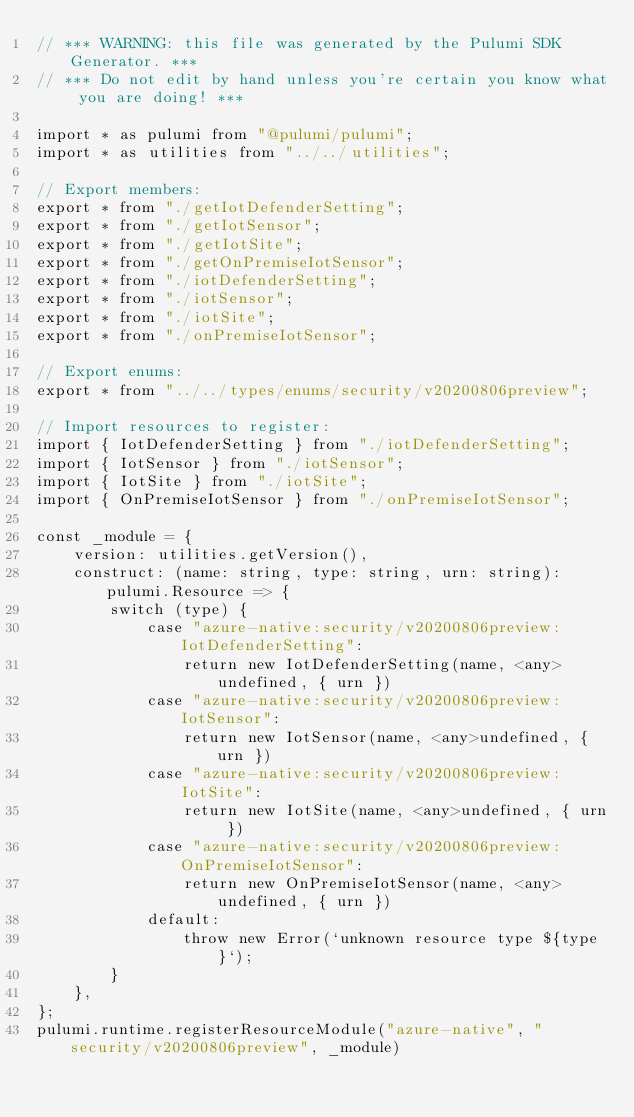Convert code to text. <code><loc_0><loc_0><loc_500><loc_500><_TypeScript_>// *** WARNING: this file was generated by the Pulumi SDK Generator. ***
// *** Do not edit by hand unless you're certain you know what you are doing! ***

import * as pulumi from "@pulumi/pulumi";
import * as utilities from "../../utilities";

// Export members:
export * from "./getIotDefenderSetting";
export * from "./getIotSensor";
export * from "./getIotSite";
export * from "./getOnPremiseIotSensor";
export * from "./iotDefenderSetting";
export * from "./iotSensor";
export * from "./iotSite";
export * from "./onPremiseIotSensor";

// Export enums:
export * from "../../types/enums/security/v20200806preview";

// Import resources to register:
import { IotDefenderSetting } from "./iotDefenderSetting";
import { IotSensor } from "./iotSensor";
import { IotSite } from "./iotSite";
import { OnPremiseIotSensor } from "./onPremiseIotSensor";

const _module = {
    version: utilities.getVersion(),
    construct: (name: string, type: string, urn: string): pulumi.Resource => {
        switch (type) {
            case "azure-native:security/v20200806preview:IotDefenderSetting":
                return new IotDefenderSetting(name, <any>undefined, { urn })
            case "azure-native:security/v20200806preview:IotSensor":
                return new IotSensor(name, <any>undefined, { urn })
            case "azure-native:security/v20200806preview:IotSite":
                return new IotSite(name, <any>undefined, { urn })
            case "azure-native:security/v20200806preview:OnPremiseIotSensor":
                return new OnPremiseIotSensor(name, <any>undefined, { urn })
            default:
                throw new Error(`unknown resource type ${type}`);
        }
    },
};
pulumi.runtime.registerResourceModule("azure-native", "security/v20200806preview", _module)
</code> 